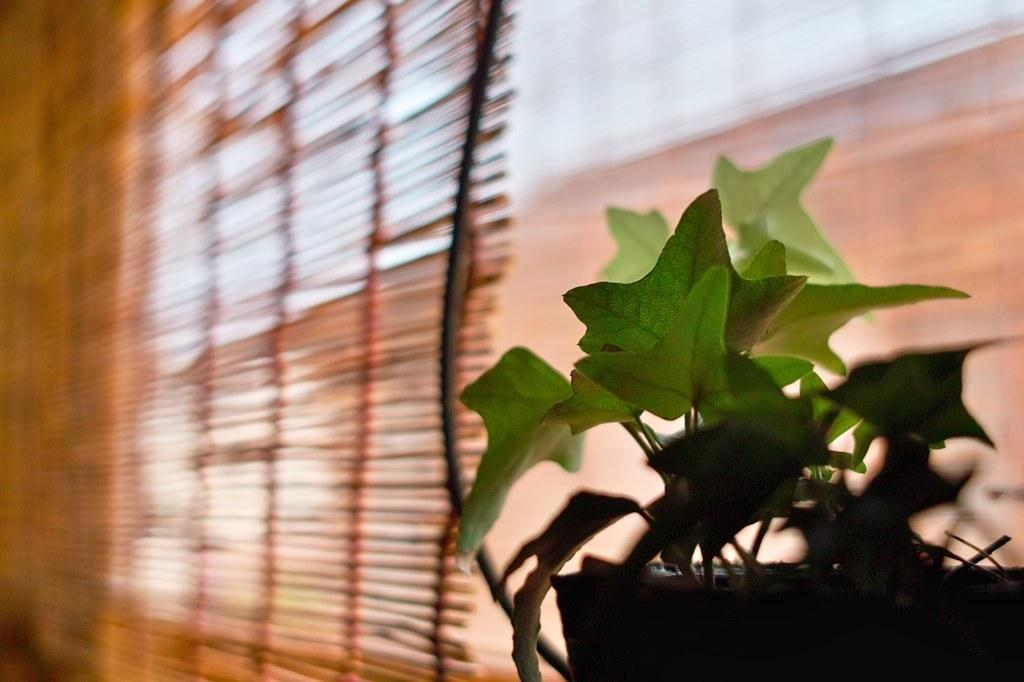What object is located on the right side of the image? There is a flower pot on the right side of the image. Can you describe the background of the image? The background of the image is blurred. What can be seen in the background of the image? Window blinds are visible in the background of the image. What type of destruction can be seen happening to the flower pot in the image? There is no destruction happening to the flower pot in the image; it appears to be intact. Can you tell me how many baseballs are visible in the image? There are no baseballs present in the image. 